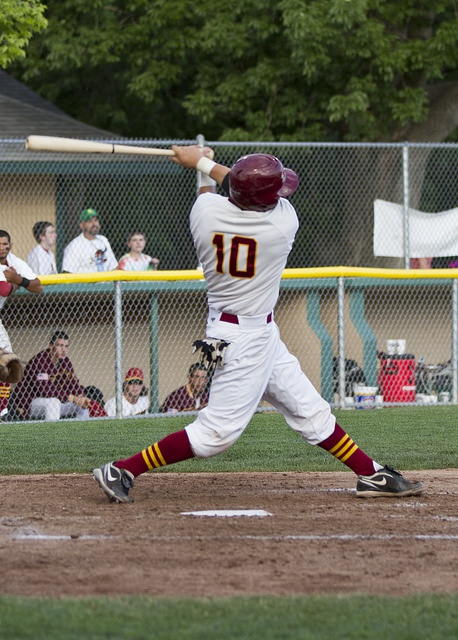Describe the objects in this image and their specific colors. I can see people in olive, lightgray, darkgray, black, and maroon tones, people in olive, black, gray, darkgray, and maroon tones, people in olive, lavender, gray, and darkgray tones, baseball bat in olive, lightgray, gray, darkgray, and tan tones, and people in olive, lightgray, gray, and darkgray tones in this image. 